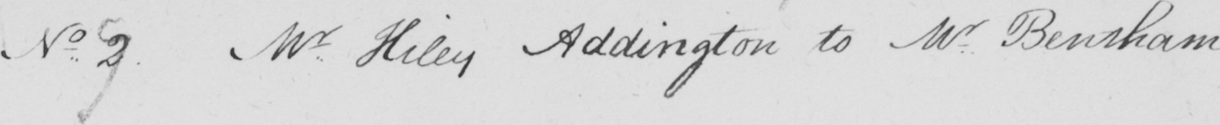Can you tell me what this handwritten text says? No 7 Mr Hiley Addington to Mr Bentham . _ 